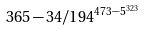<formula> <loc_0><loc_0><loc_500><loc_500>3 6 5 - 3 4 / 1 9 4 ^ { 4 7 3 - 5 ^ { 3 2 3 } }</formula> 